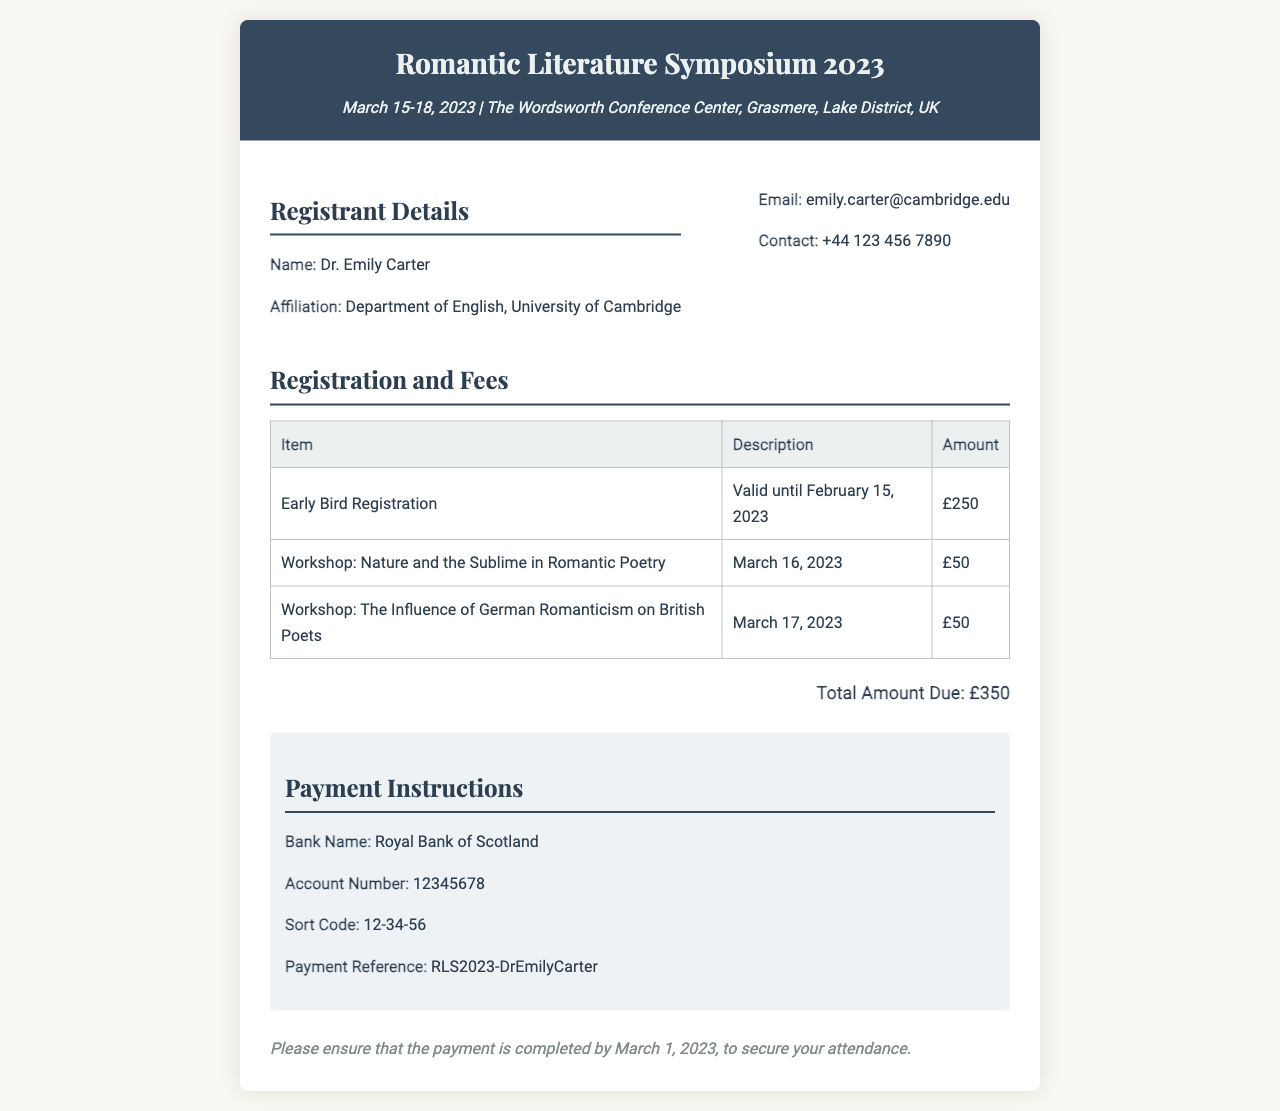What is the name of the registrant? The name of the registrant is provided in the registrant details section of the invoice.
Answer: Dr. Emily Carter What is the total amount due? The total amount due is mentioned in the fees section of the invoice.
Answer: £350 What is the early bird registration amount? The early bird registration amount is listed in the fees table of the invoice.
Answer: £250 When is the deadline for early bird registration? The deadline for early bird registration is stated in the description next to the early bird registration amount.
Answer: February 15, 2023 Which workshop is scheduled for March 16, 2023? The workshop scheduled for March 16, 2023, is mentioned in the fees table of the invoice.
Answer: Nature and the Sublime in Romantic Poetry What is the payment reference code? The payment reference code can be found in the payment instructions section of the invoice.
Answer: RLS2023-DrEmilyCarter What is the name of the bank for payment? The name of the bank is provided in the payment instructions section of the invoice.
Answer: Royal Bank of Scotland How many workshops are listed in the invoice? The number of workshops can be counted from the fees table in the invoice.
Answer: 2 